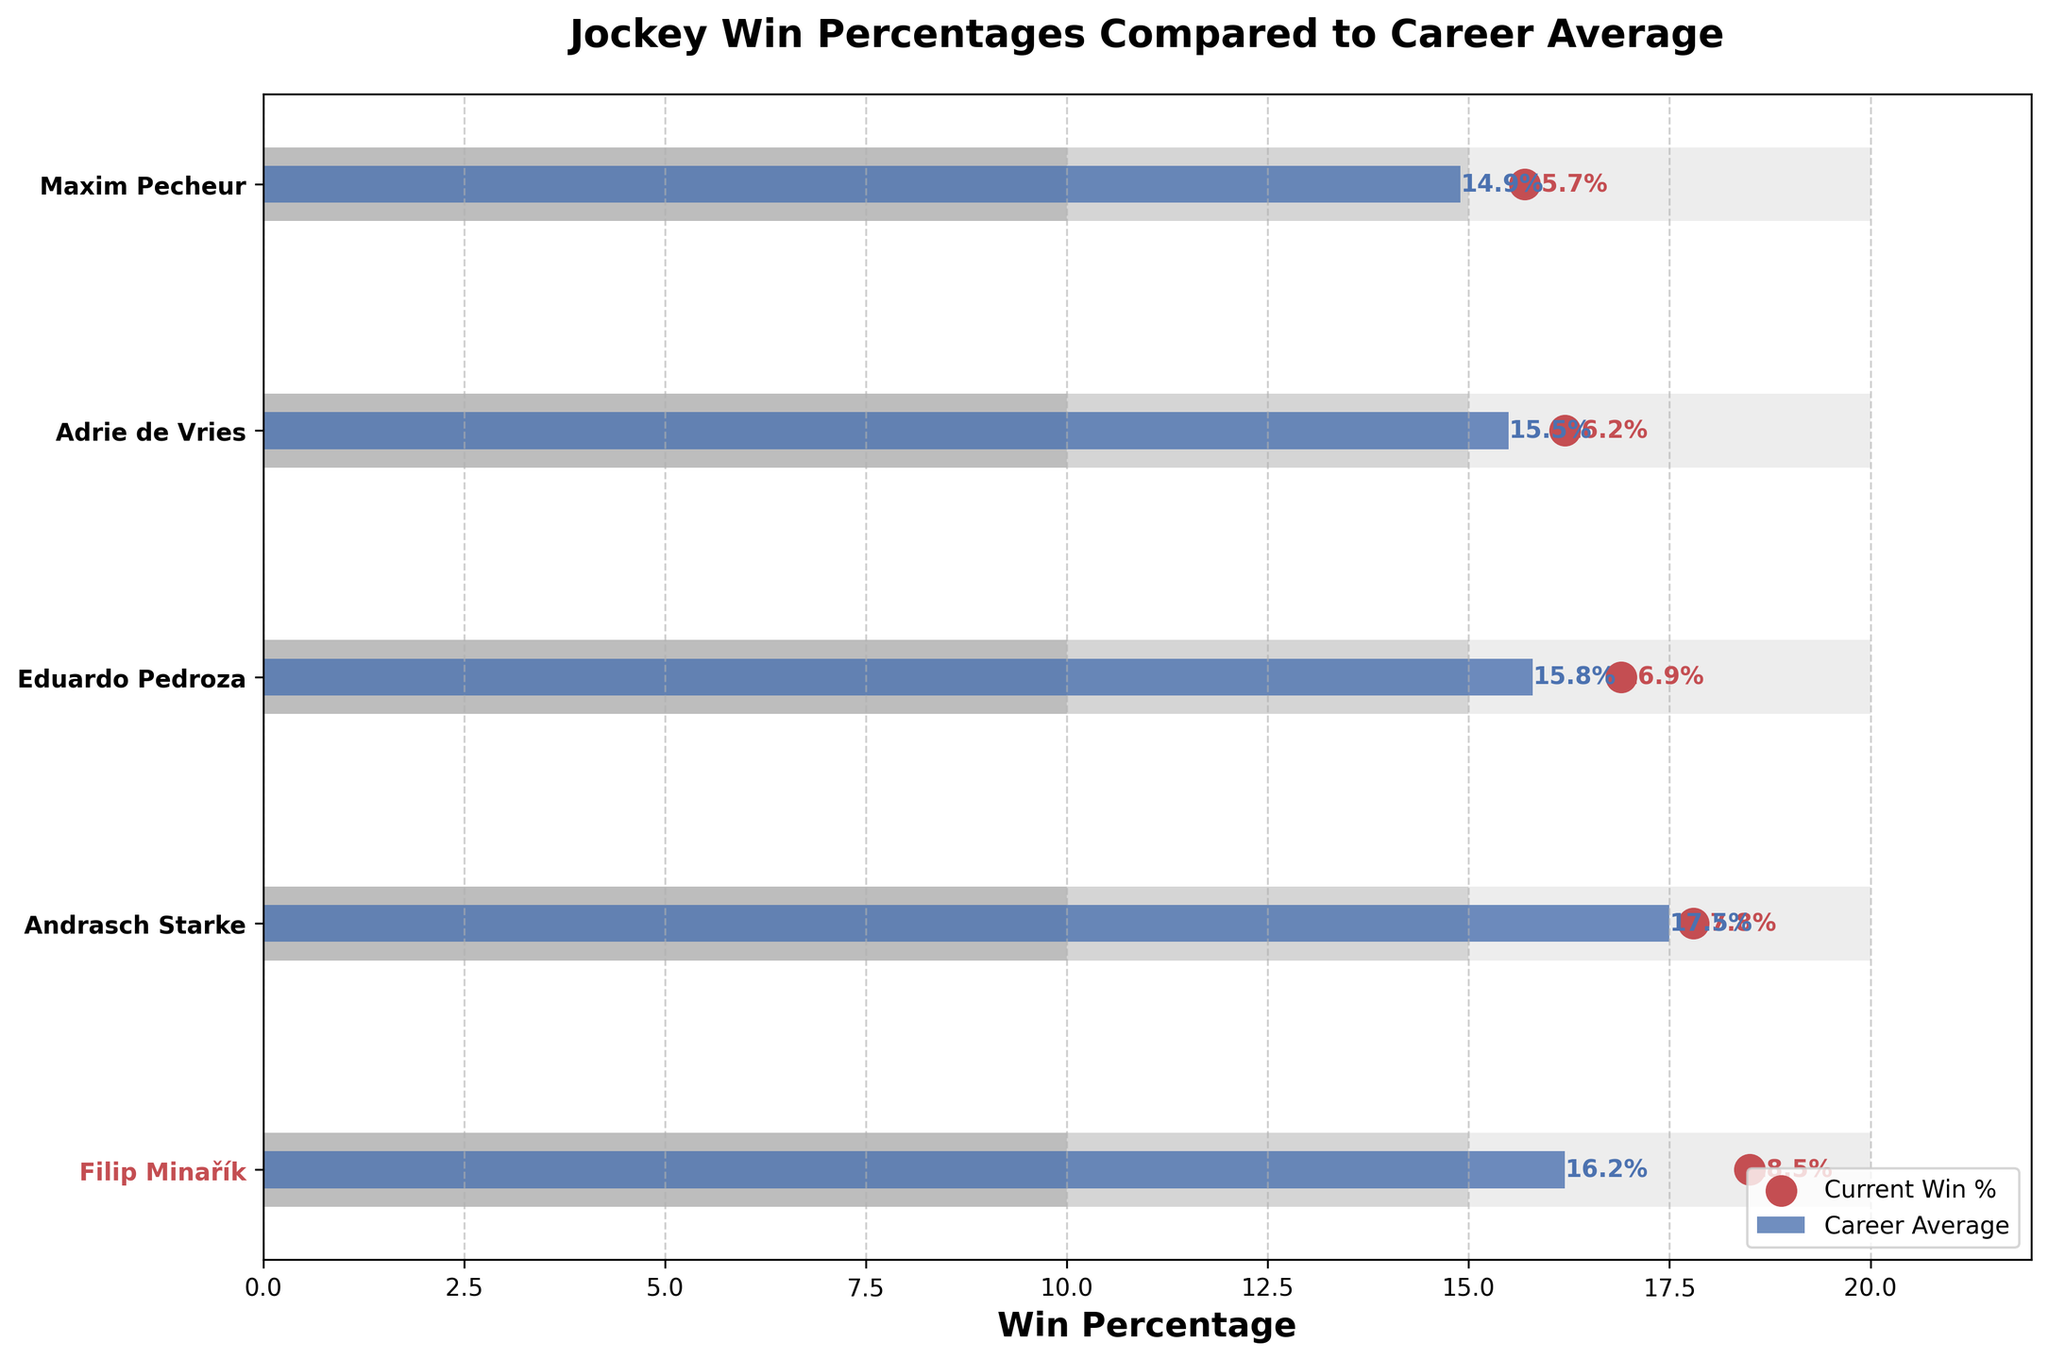How many jockeys are featured in the chart? The y-axis of the chart lists the jockeys being compared. Counting the number of names gives us the total number of jockeys featured.
Answer: 5 What is the title of the chart? The title is typically found at the top of the chart. Read the text found in this area.
Answer: Jockey Win Percentages Compared to Career Average What are the win percentages for Filip Minařík in the current year and his career average? Identify Filip Minařík's position on the y-axis and then look at the corresponding points along the x-axis for both the scatter (current year) and the bar (career average).
Answer: 18.5%, 16.2% Which jockey has the highest current win percentage? Compare the scatter points for all jockeys and identify which is the furthest to the right on the horizontal axis.
Answer: Filip Minařík Which jockey has a current win percentage below their career average? Check each jockey's current win percentage (scatter point) against their career average (bar). Identify those where the scatter point is to the left of the bar.
Answer: Andrasch Starke, Adrie de Vries, Maxim Pecheur What is the range for Filip Minařík? The bullet chart uses shaded bars to show ranges for each jockey. These ranges are divided into three sections of different shades. Locate Filip’s range values as indicated in the chart data.
Answer: 10% - 20% How does Filip Minařík’s current win percentage compare to his career average? Compare the scatter point and the bar representing his career average. Identify if the current point is higher or lower.
Answer: Higher Which jockey has the smallest difference between their current win percentage and career average? Calculate the difference between the current win percentage and career average for each jockey, then find the smallest value.
Answer: Andrasch Starke How many jockeys have a current win percentage within the 10-15% range? Look at the scatter points to see which fall within the 10-15% range on the horizontal axis.
Answer: 0 What is the average difference between the current win percentage and career average for all jockeys? Calculate the difference for each jockey, sum these differences, and then divide by the number of jockeys. The differences are: Filip Minařík (2.3), Andrasch Starke (0.3), Eduardo Pedroza (1.1), Adrie de Vries (0.7), Maxim Pecheur (0.8). Sum these values: 2.3 + 0.3 + 1.1 + 0.7 + 0.8 = 5.2. Divide by the number of jockeys: 5.2 / 5 = 1.04
Answer: 1.04 